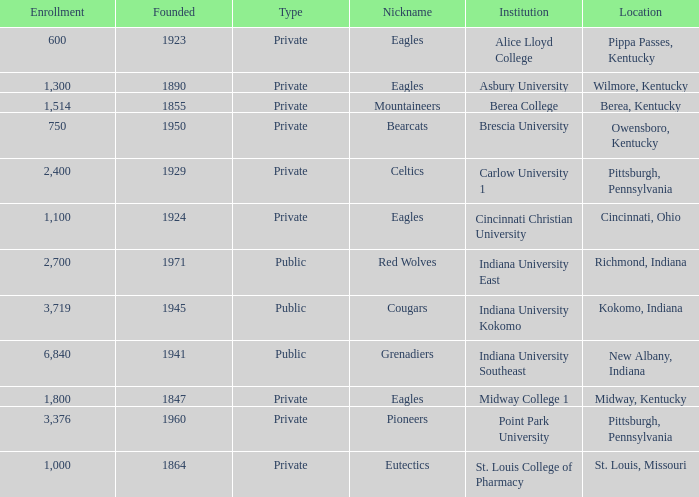Which college's enrollment is less than 1,000? Alice Lloyd College, Brescia University. 